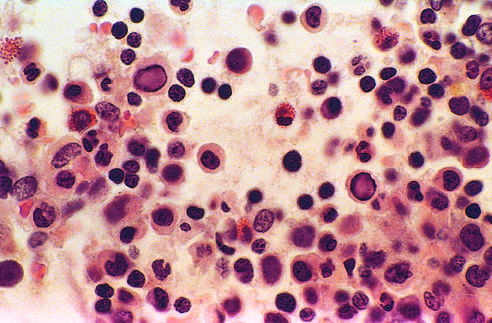s h&e infected with parvovirus b19?
Answer the question using a single word or phrase. No 